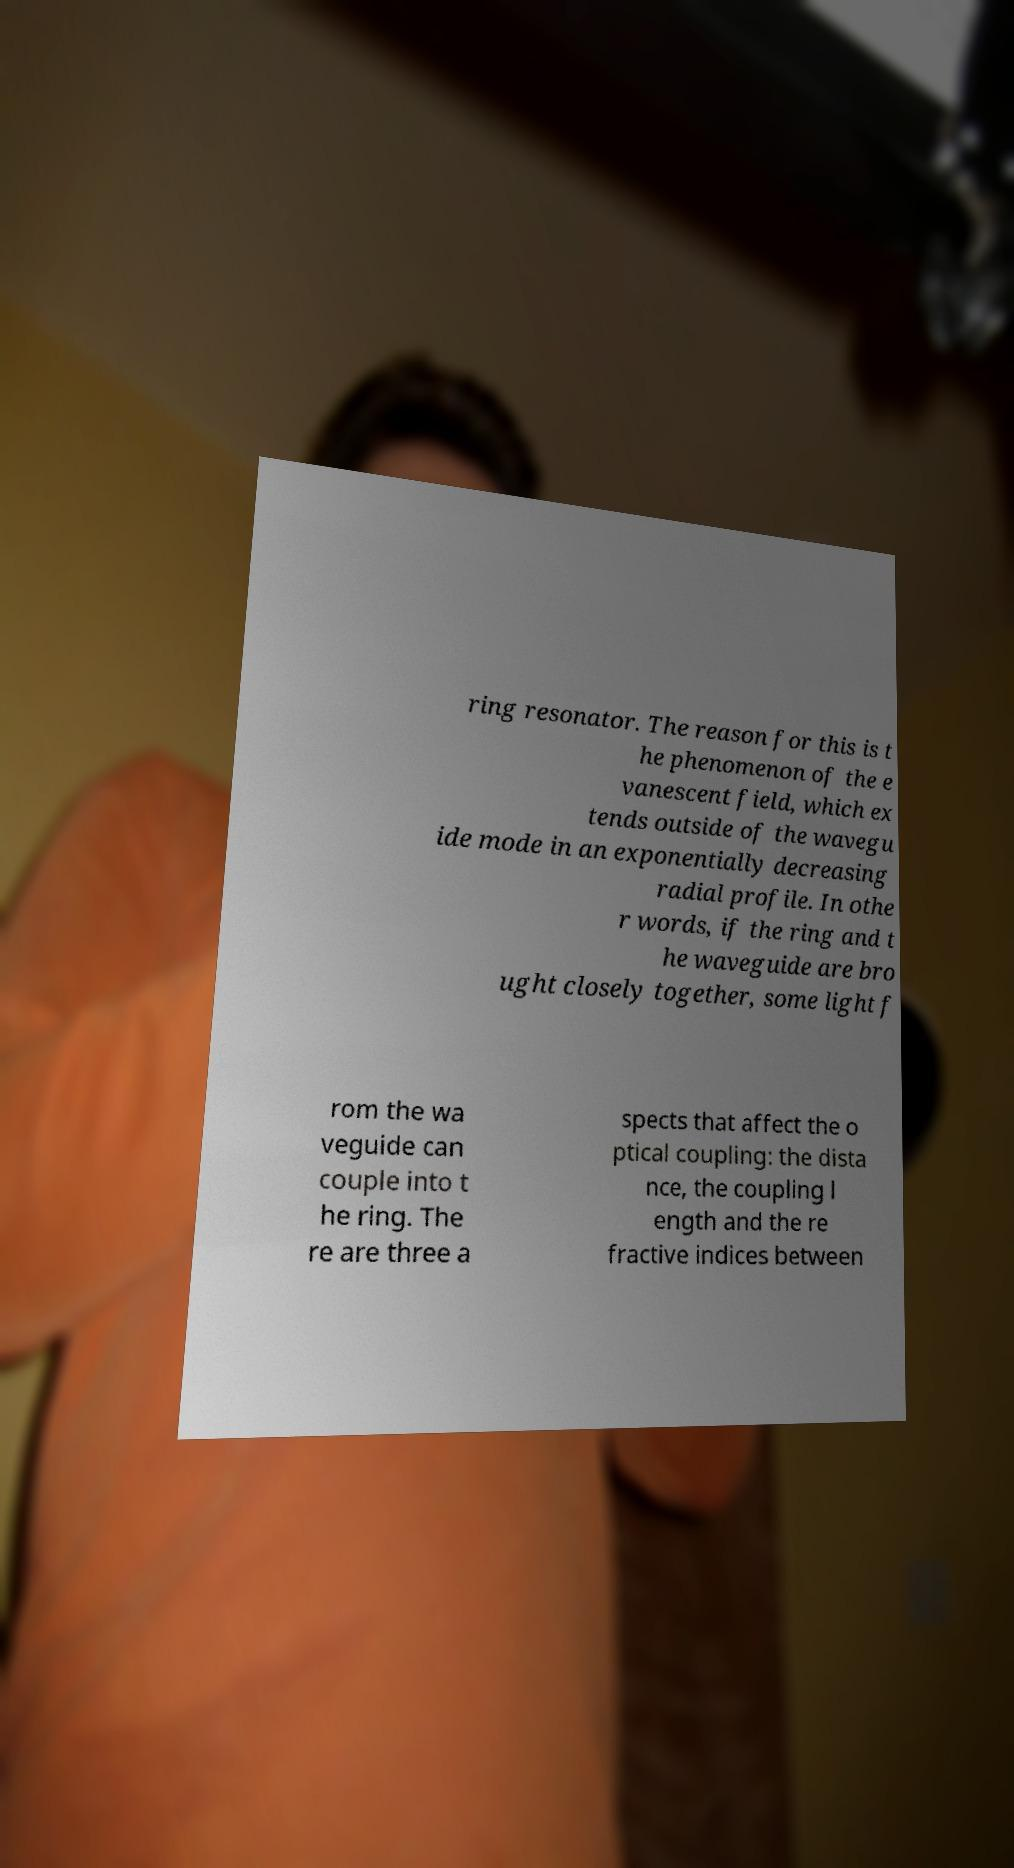I need the written content from this picture converted into text. Can you do that? ring resonator. The reason for this is t he phenomenon of the e vanescent field, which ex tends outside of the wavegu ide mode in an exponentially decreasing radial profile. In othe r words, if the ring and t he waveguide are bro ught closely together, some light f rom the wa veguide can couple into t he ring. The re are three a spects that affect the o ptical coupling: the dista nce, the coupling l ength and the re fractive indices between 